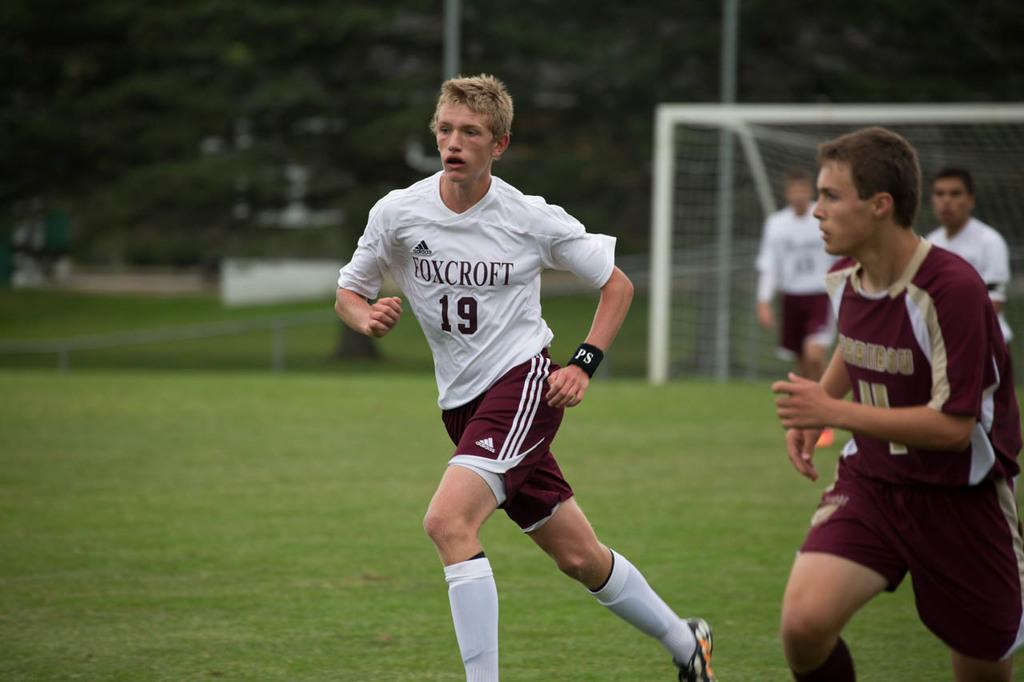<image>
Share a concise interpretation of the image provided. Number 19 from Foxcroft is running during a soccer game. 